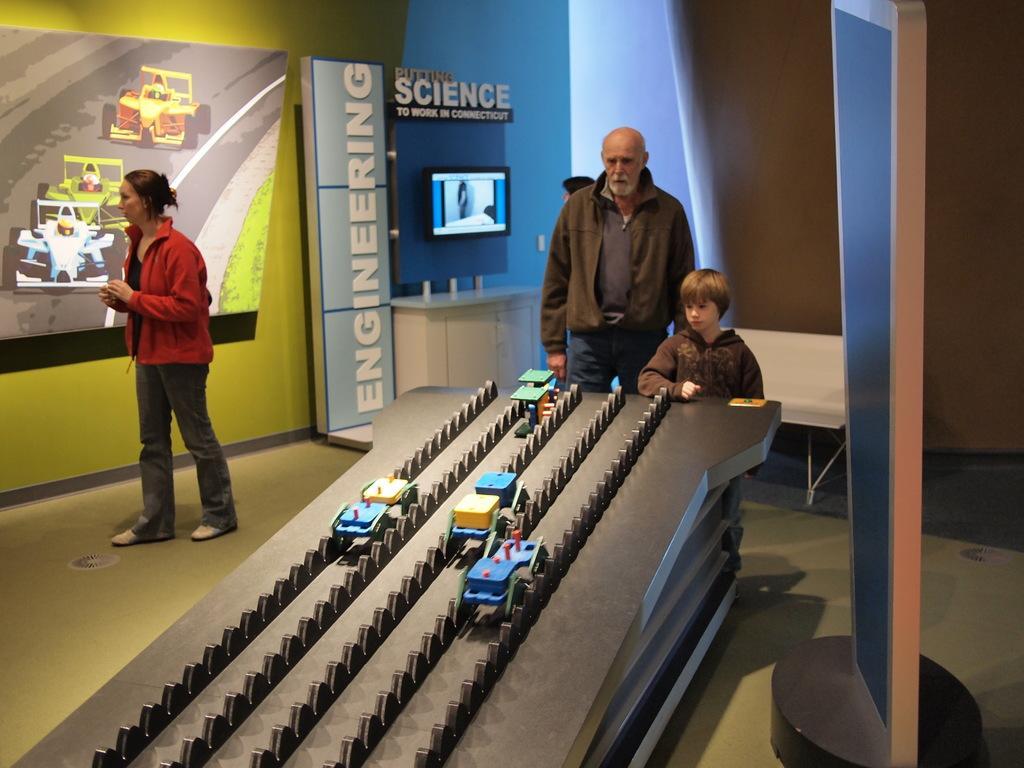Can you describe this image briefly? In this image we can see a group of people standing. one woman is wearing a red coat. In the foreground of the image we can see group of toys placed on a table. In the background, we can see a television on the wall, cupboard, poster and a photo frame on the wall. 